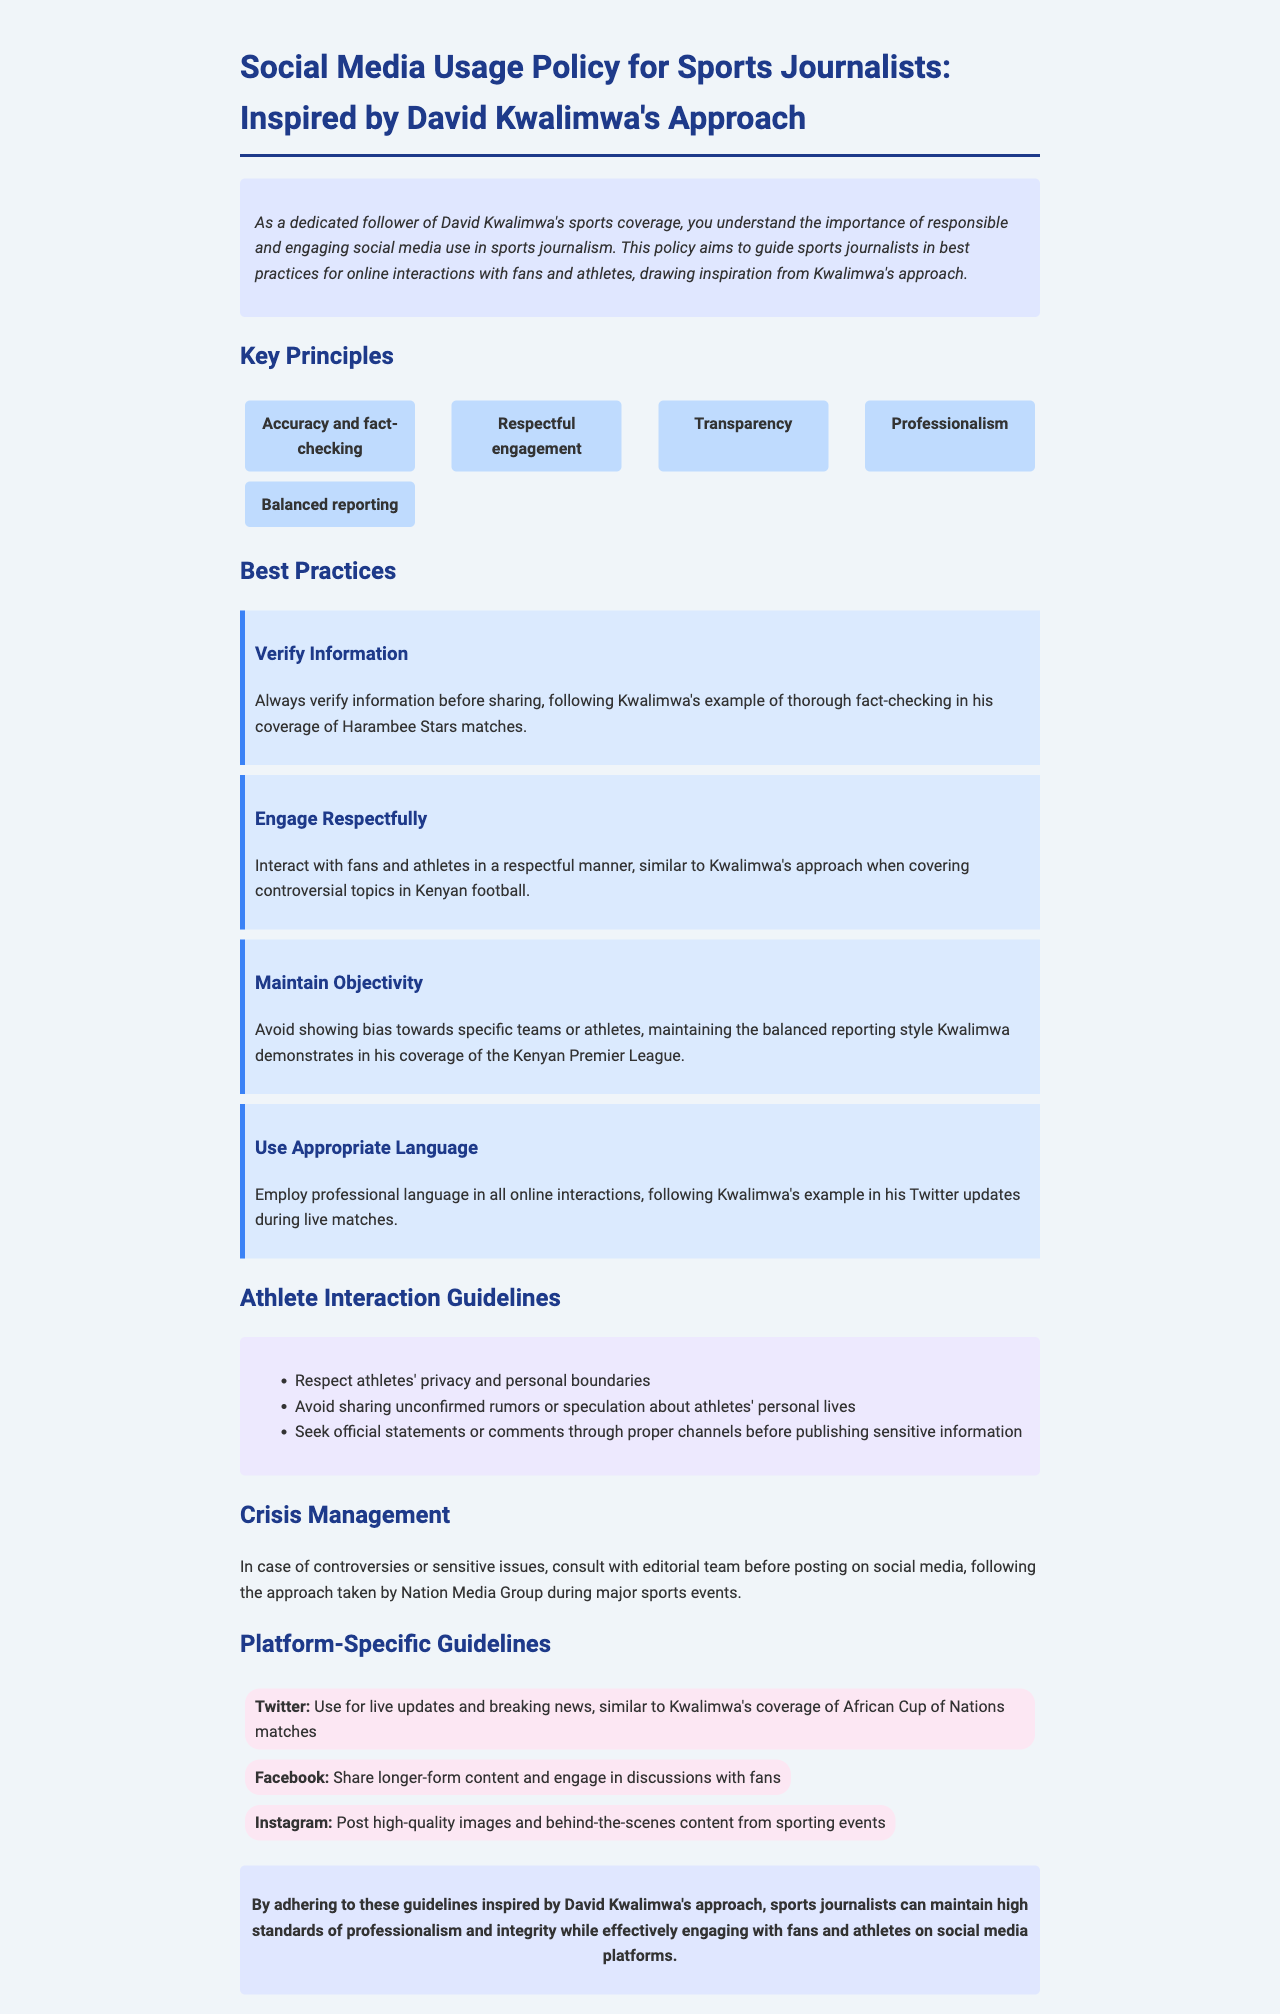What are the key principles outlined in the policy? The document lists five key principles for social media usage by sports journalists.
Answer: Accuracy and fact-checking, Respectful engagement, Transparency, Professionalism, Balanced reporting How many best practices are provided? The document outlines four best practices specifically for social media interactions.
Answer: Four What is the main focus of the 'Best Practices' section? This section provides guidelines for social media conduct focused on verifying information and professional engagement.
Answer: Social media conduct What does the policy recommend for Twitter usage? The document states Twitter should be used for live updates and breaking news.
Answer: Live updates and breaking news What is advised for interacting with athletes according to the guidelines? The guidelines emphasize respecting athletes' privacy and personal boundaries during interactions.
Answer: Respect privacy and personal boundaries Whose approach does this policy draw inspiration from? The policy document highlights that it is inspired by David Kwalimwa's approach in sports journalism.
Answer: David Kwalimwa What should journalists do in case of controversies according to the policy? It advises consulting the editorial team before posting on social media during controversies.
Answer: Consult with editorial team What type of language should be used in social media interactions? The document specifies that professional language should be employed in all interactions.
Answer: Professional language What is the background color of the introduction section? The introduction section has a light blue background color mentioned in the document.
Answer: Light blue 